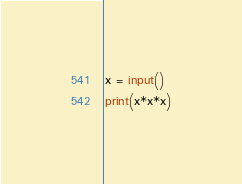<code> <loc_0><loc_0><loc_500><loc_500><_Python_>x = input()
print(x*x*x)</code> 